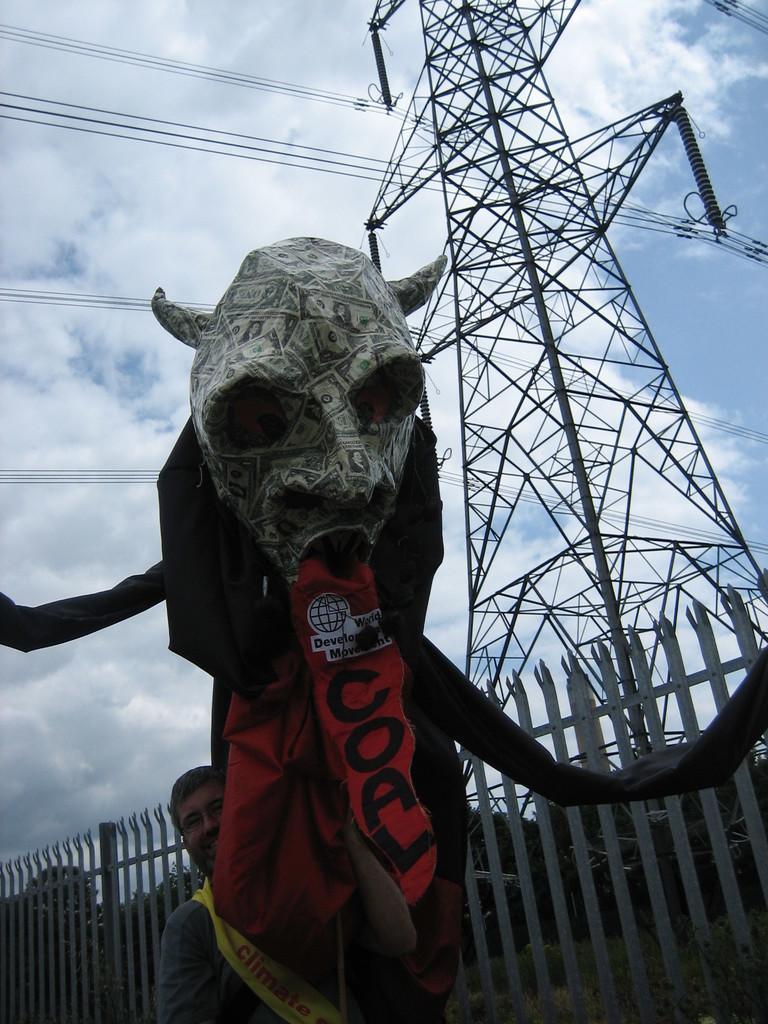Can you describe this image briefly? This picture is clicked outside. In the center we can see a person holding some objects. In the background we can see the sky with the clouds and we can see the metal rods, cables, fence and some other objects. 